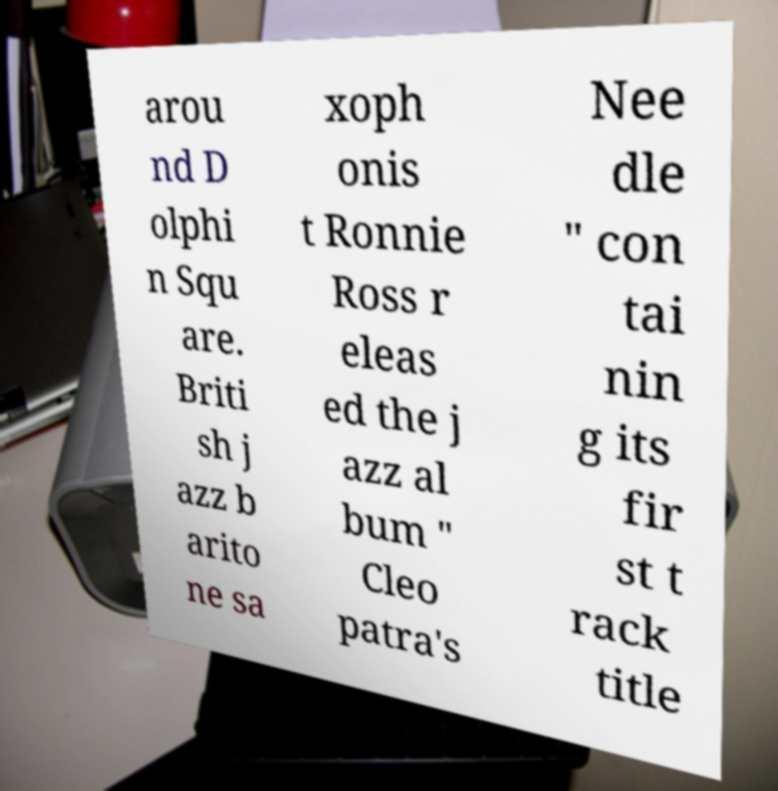Could you assist in decoding the text presented in this image and type it out clearly? arou nd D olphi n Squ are. Briti sh j azz b arito ne sa xoph onis t Ronnie Ross r eleas ed the j azz al bum " Cleo patra's Nee dle " con tai nin g its fir st t rack title 